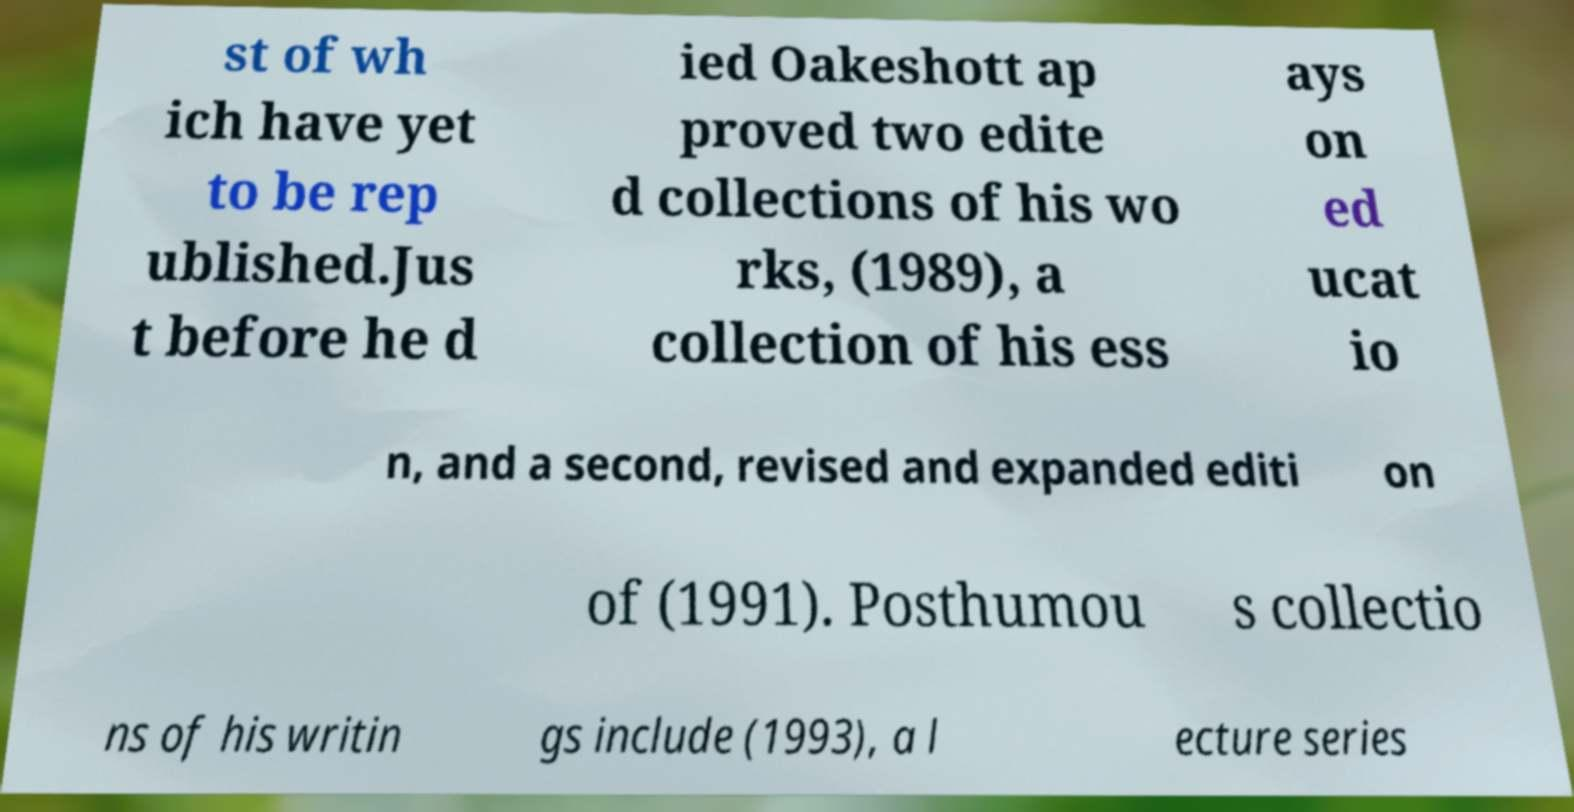For documentation purposes, I need the text within this image transcribed. Could you provide that? st of wh ich have yet to be rep ublished.Jus t before he d ied Oakeshott ap proved two edite d collections of his wo rks, (1989), a collection of his ess ays on ed ucat io n, and a second, revised and expanded editi on of (1991). Posthumou s collectio ns of his writin gs include (1993), a l ecture series 